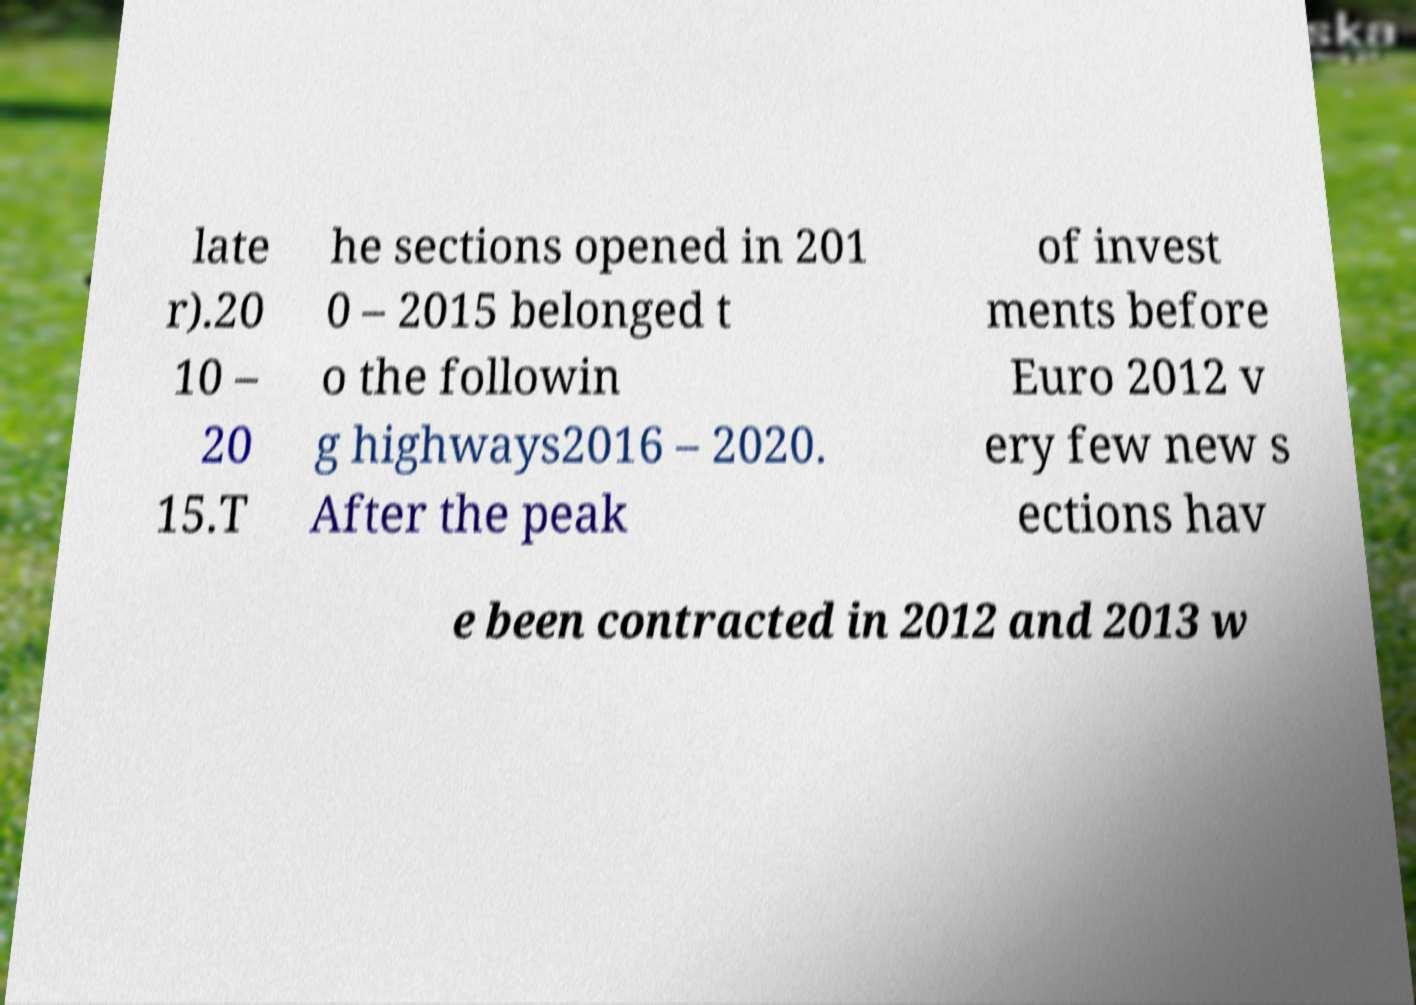Please identify and transcribe the text found in this image. late r).20 10 – 20 15.T he sections opened in 201 0 – 2015 belonged t o the followin g highways2016 – 2020. After the peak of invest ments before Euro 2012 v ery few new s ections hav e been contracted in 2012 and 2013 w 